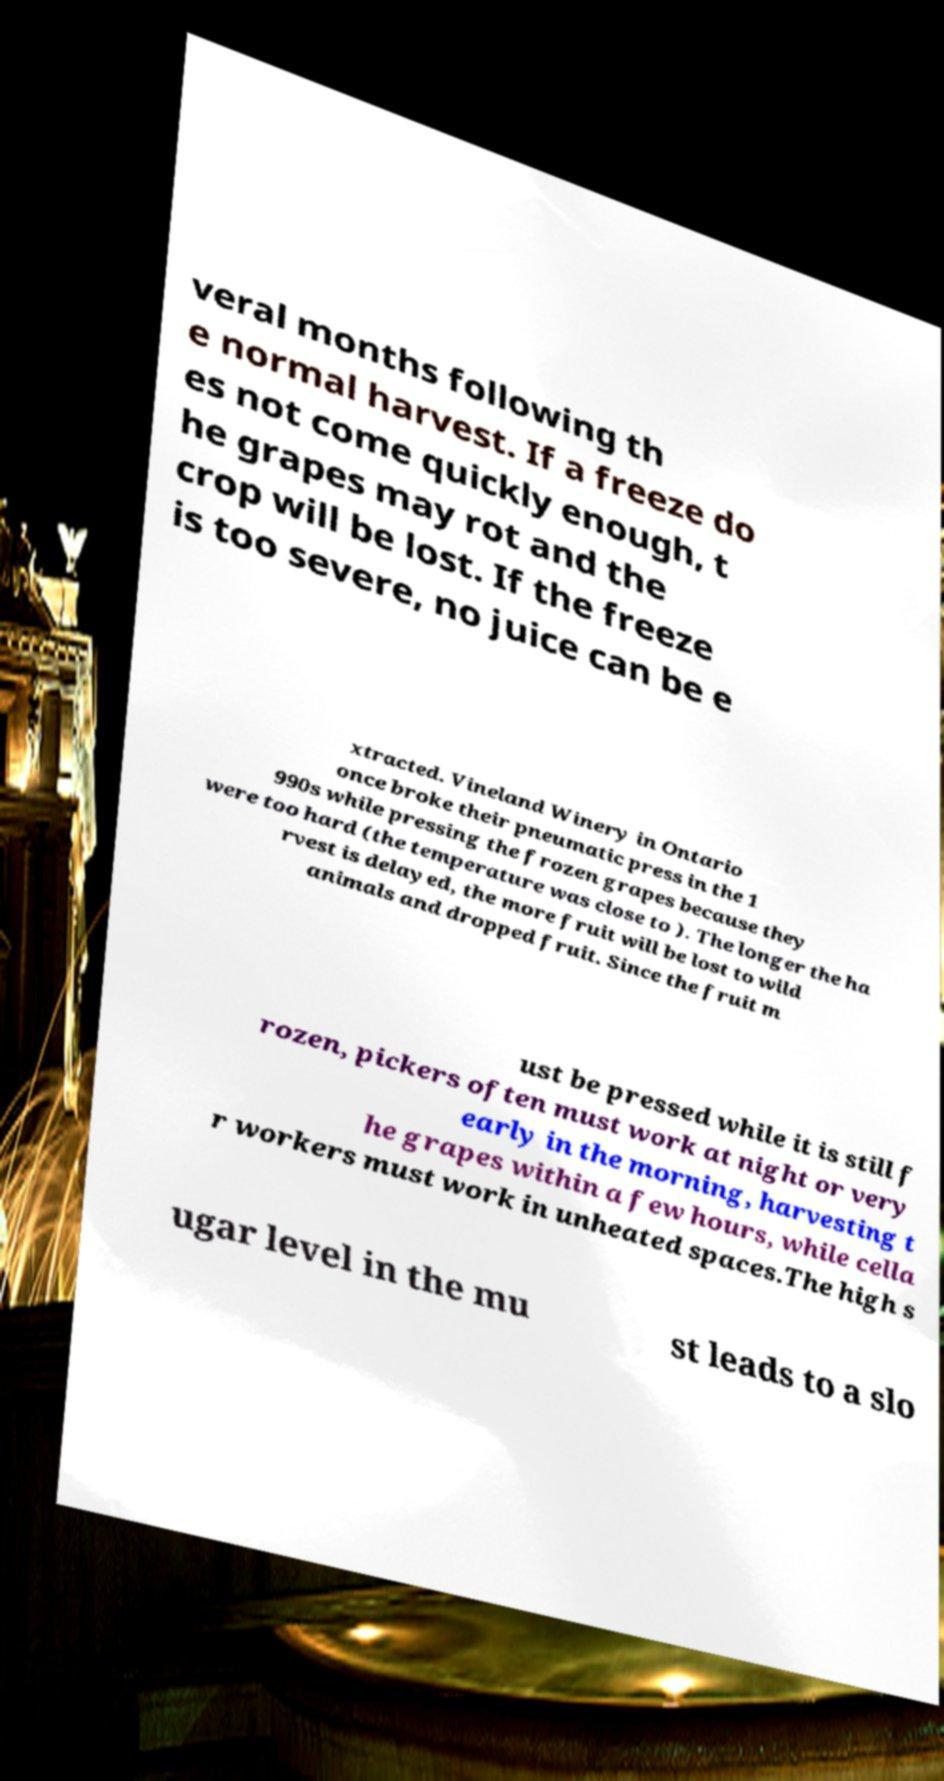Please read and relay the text visible in this image. What does it say? veral months following th e normal harvest. If a freeze do es not come quickly enough, t he grapes may rot and the crop will be lost. If the freeze is too severe, no juice can be e xtracted. Vineland Winery in Ontario once broke their pneumatic press in the 1 990s while pressing the frozen grapes because they were too hard (the temperature was close to ). The longer the ha rvest is delayed, the more fruit will be lost to wild animals and dropped fruit. Since the fruit m ust be pressed while it is still f rozen, pickers often must work at night or very early in the morning, harvesting t he grapes within a few hours, while cella r workers must work in unheated spaces.The high s ugar level in the mu st leads to a slo 